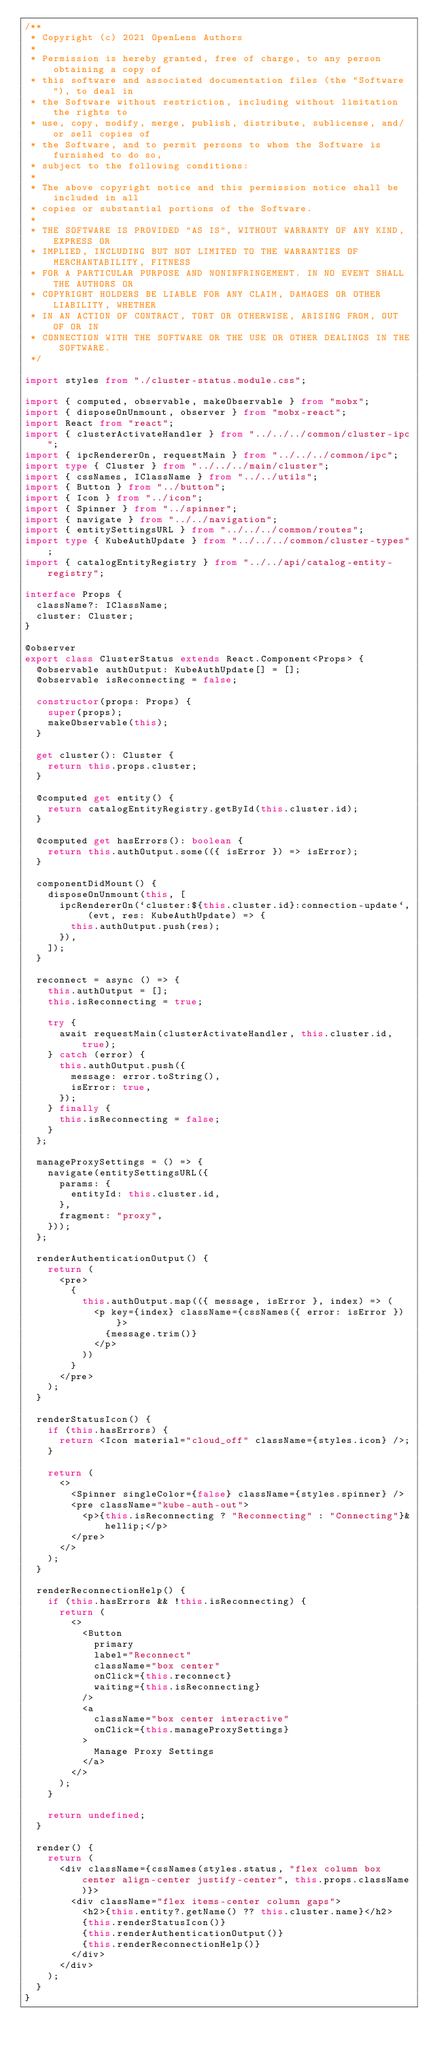<code> <loc_0><loc_0><loc_500><loc_500><_TypeScript_>/**
 * Copyright (c) 2021 OpenLens Authors
 *
 * Permission is hereby granted, free of charge, to any person obtaining a copy of
 * this software and associated documentation files (the "Software"), to deal in
 * the Software without restriction, including without limitation the rights to
 * use, copy, modify, merge, publish, distribute, sublicense, and/or sell copies of
 * the Software, and to permit persons to whom the Software is furnished to do so,
 * subject to the following conditions:
 *
 * The above copyright notice and this permission notice shall be included in all
 * copies or substantial portions of the Software.
 *
 * THE SOFTWARE IS PROVIDED "AS IS", WITHOUT WARRANTY OF ANY KIND, EXPRESS OR
 * IMPLIED, INCLUDING BUT NOT LIMITED TO THE WARRANTIES OF MERCHANTABILITY, FITNESS
 * FOR A PARTICULAR PURPOSE AND NONINFRINGEMENT. IN NO EVENT SHALL THE AUTHORS OR
 * COPYRIGHT HOLDERS BE LIABLE FOR ANY CLAIM, DAMAGES OR OTHER LIABILITY, WHETHER
 * IN AN ACTION OF CONTRACT, TORT OR OTHERWISE, ARISING FROM, OUT OF OR IN
 * CONNECTION WITH THE SOFTWARE OR THE USE OR OTHER DEALINGS IN THE SOFTWARE.
 */

import styles from "./cluster-status.module.css";

import { computed, observable, makeObservable } from "mobx";
import { disposeOnUnmount, observer } from "mobx-react";
import React from "react";
import { clusterActivateHandler } from "../../../common/cluster-ipc";
import { ipcRendererOn, requestMain } from "../../../common/ipc";
import type { Cluster } from "../../../main/cluster";
import { cssNames, IClassName } from "../../utils";
import { Button } from "../button";
import { Icon } from "../icon";
import { Spinner } from "../spinner";
import { navigate } from "../../navigation";
import { entitySettingsURL } from "../../../common/routes";
import type { KubeAuthUpdate } from "../../../common/cluster-types";
import { catalogEntityRegistry } from "../../api/catalog-entity-registry";

interface Props {
  className?: IClassName;
  cluster: Cluster;
}

@observer
export class ClusterStatus extends React.Component<Props> {
  @observable authOutput: KubeAuthUpdate[] = [];
  @observable isReconnecting = false;

  constructor(props: Props) {
    super(props);
    makeObservable(this);
  }

  get cluster(): Cluster {
    return this.props.cluster;
  }

  @computed get entity() {
    return catalogEntityRegistry.getById(this.cluster.id);
  }

  @computed get hasErrors(): boolean {
    return this.authOutput.some(({ isError }) => isError);
  }

  componentDidMount() {
    disposeOnUnmount(this, [
      ipcRendererOn(`cluster:${this.cluster.id}:connection-update`, (evt, res: KubeAuthUpdate) => {
        this.authOutput.push(res);
      }),
    ]);
  }

  reconnect = async () => {
    this.authOutput = [];
    this.isReconnecting = true;

    try {
      await requestMain(clusterActivateHandler, this.cluster.id, true);
    } catch (error) {
      this.authOutput.push({
        message: error.toString(),
        isError: true,
      });
    } finally {
      this.isReconnecting = false;
    }
  };

  manageProxySettings = () => {
    navigate(entitySettingsURL({
      params: {
        entityId: this.cluster.id,
      },
      fragment: "proxy",
    }));
  };

  renderAuthenticationOutput() {
    return (
      <pre>
        {
          this.authOutput.map(({ message, isError }, index) => (
            <p key={index} className={cssNames({ error: isError })}>
              {message.trim()}
            </p>
          ))
        }
      </pre>
    );
  }

  renderStatusIcon() {
    if (this.hasErrors) {
      return <Icon material="cloud_off" className={styles.icon} />;
    }

    return (
      <>
        <Spinner singleColor={false} className={styles.spinner} />
        <pre className="kube-auth-out">
          <p>{this.isReconnecting ? "Reconnecting" : "Connecting"}&hellip;</p>
        </pre>
      </>
    );
  }

  renderReconnectionHelp() {
    if (this.hasErrors && !this.isReconnecting) {
      return (
        <>
          <Button
            primary
            label="Reconnect"
            className="box center"
            onClick={this.reconnect}
            waiting={this.isReconnecting}
          />
          <a
            className="box center interactive"
            onClick={this.manageProxySettings}
          >
            Manage Proxy Settings
          </a>
        </>
      );
    }

    return undefined;
  }

  render() {
    return (
      <div className={cssNames(styles.status, "flex column box center align-center justify-center", this.props.className)}>
        <div className="flex items-center column gaps">
          <h2>{this.entity?.getName() ?? this.cluster.name}</h2>
          {this.renderStatusIcon()}
          {this.renderAuthenticationOutput()}
          {this.renderReconnectionHelp()}
        </div>
      </div>
    );
  }
}
</code> 